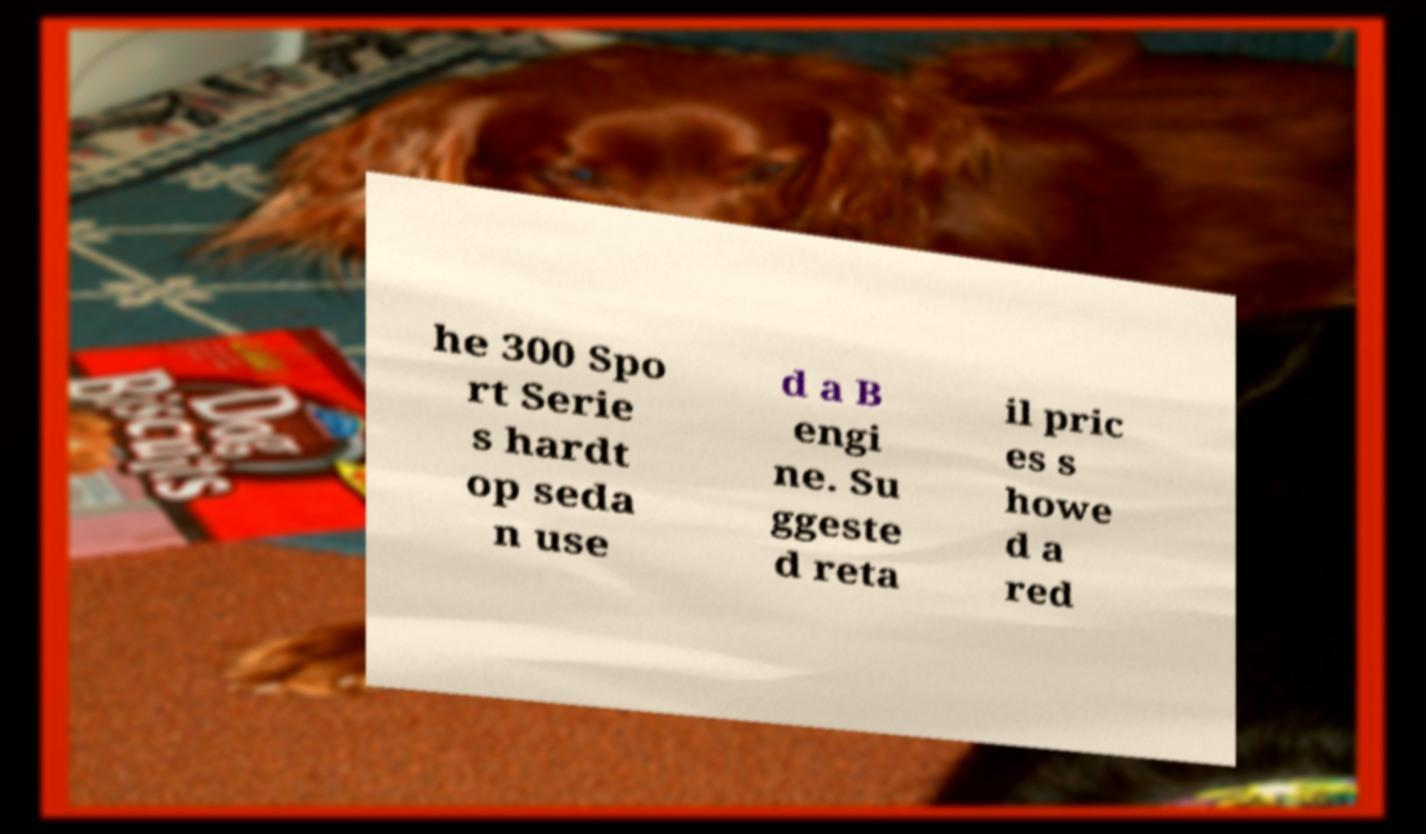Could you assist in decoding the text presented in this image and type it out clearly? he 300 Spo rt Serie s hardt op seda n use d a B engi ne. Su ggeste d reta il pric es s howe d a red 